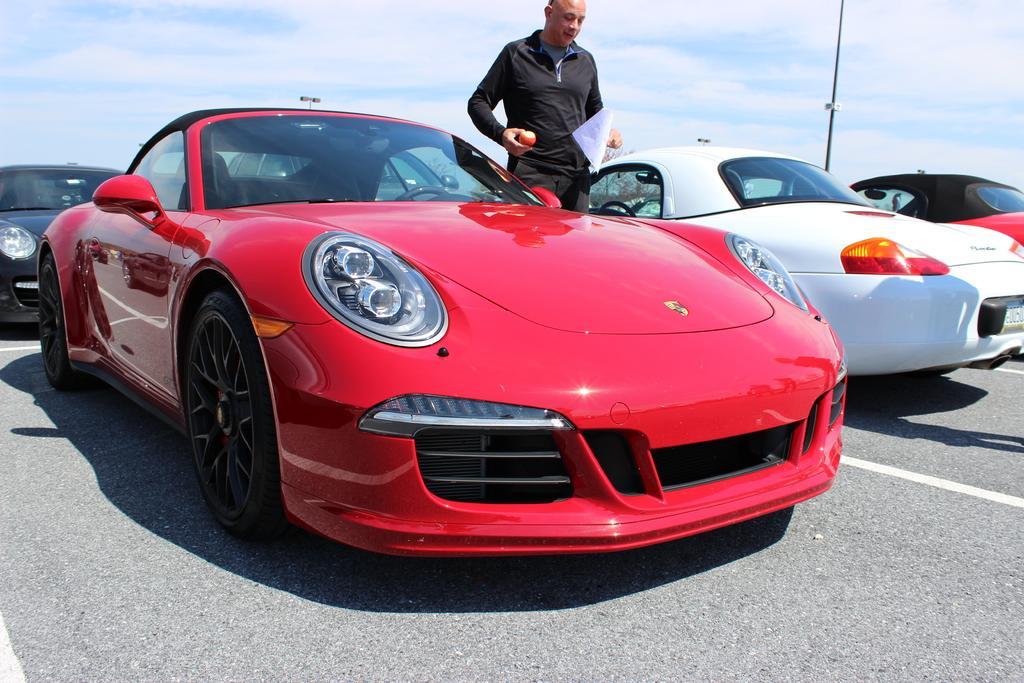Can you describe this image briefly? There are cars and a person is standing wearing a black dress and holding a paper and a fruit. There is a pole at the back and sky at the top. 